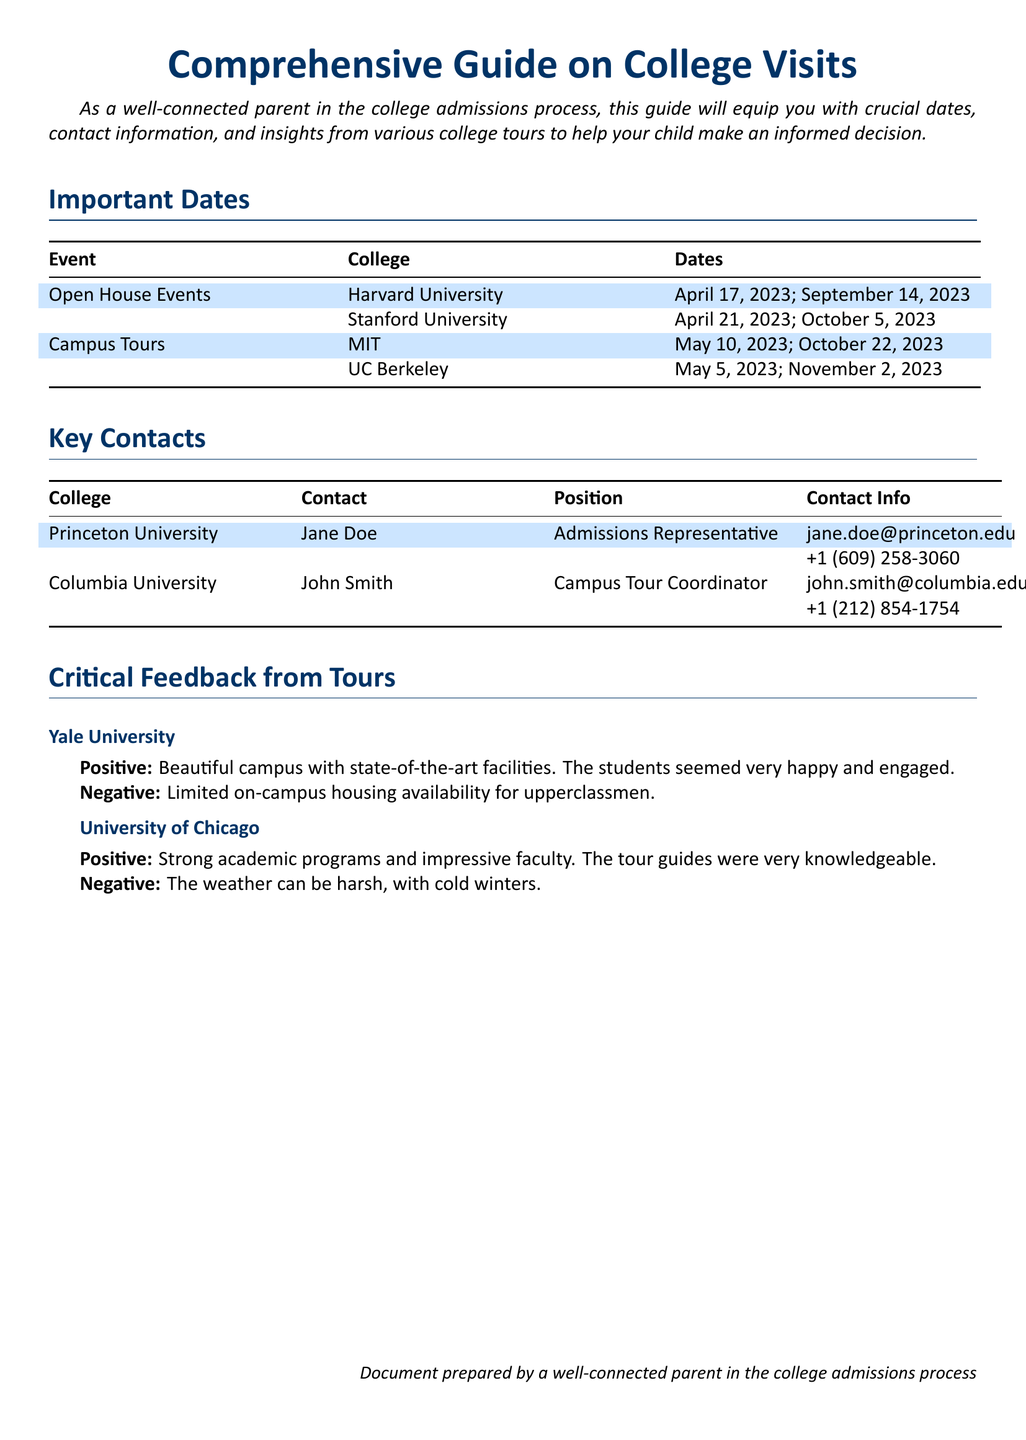What are the open house event dates for Stanford University? The open house event dates for Stanford University listed in the document are April 21, 2023 and October 5, 2023.
Answer: April 21, 2023; October 5, 2023 Who is the Admissions Representative for Princeton University? The document specifies Jane Doe as the Admissions Representative for Princeton University.
Answer: Jane Doe What is the contact information for the Campus Tour Coordinator at Columbia University? The contact information for John Smith, the Campus Tour Coordinator at Columbia University, is provided as john.smith@columbia.edu and +1 (212) 854-1754.
Answer: john.smith@columbia.edu; +1 (212) 854-1754 What negative feedback was provided for Yale University? The document states that limited on-campus housing availability for upperclassmen is the negative feedback from the tour of Yale University.
Answer: Limited on-campus housing availability for upperclassmen Which college has a campus tour date on October 22, 2023? The document indicates that MIT has a campus tour date on October 22, 2023.
Answer: MIT 